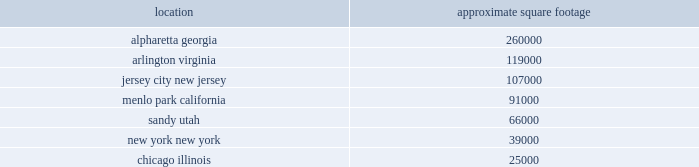Item 2 .
Properties a summary of our significant locations at december 31 , 2011 is shown in the table .
All facilities are leased , except for 165000 square feet of our office in alpharetta , georgia .
Square footage amounts are net of space that has been sublet or part of a facility restructuring. .
All of our facilities are used by either our trading and investing or balance sheet management segments , in addition to the corporate/other category .
All other leased facilities with space of less than 25000 square feet are not listed by location .
In addition to the significant facilities above , we also lease all 28 e*trade branches , ranging in space from approximately 2500 to 7000 square feet .
We believe our facilities space is adequate to meet our needs in 2012 .
Item 3 .
Legal proceedings on october 27 , 2000 , ajaxo , inc .
( 201cajaxo 201d ) filed a complaint in the superior court for the state of california , county of santa clara .
Ajaxo sought damages and certain non-monetary relief for the company 2019s alleged breach of a non-disclosure agreement with ajaxo pertaining to certain wireless technology that ajaxo offered the company as well as damages and other relief against the company for their alleged misappropriation of ajaxo 2019s trade secrets .
Following a jury trial , a judgment was entered in 2003 in favor of ajaxo against the company for $ 1.3 million for breach of the ajaxo non-disclosure agreement .
Although the jury found in favor of ajaxo on its claim against the company for misappropriation of trade secrets , the trial court subsequently denied ajaxo 2019s requests for additional damages and relief .
On december 21 , 2005 , the california court of appeal affirmed the above-described award against the company for breach of the nondisclosure agreement but remanded the case to the trial court for the limited purpose of determining what , if any , additional damages ajaxo may be entitled to as a result of the jury 2019s previous finding in favor of ajaxo on its claim against the company for misappropriation of trade secrets .
Although the company paid ajaxo the full amount due on the above-described judgment , the case was remanded back to the trial court , and on may 30 , 2008 , a jury returned a verdict in favor of the company denying all claims raised and demands for damages against the company .
Following the trial court 2019s filing of entry of judgment in favor of the company on september 5 , 2008 , ajaxo filed post-trial motions for vacating this entry of judgment and requesting a new trial .
By order dated november 4 , 2008 , the trial court denied these motions .
On december 2 , 2008 , ajaxo filed a notice of appeal with the court of appeal of the state of california for the sixth district .
Oral argument on the appeal was heard on july 15 , 2010 .
On august 30 , 2010 , the court of appeal affirmed the trial court 2019s verdict in part and reversed the verdict in part , remanding the case .
E*trade petitioned the supreme court of california for review of the court of appeal decision .
On december 16 , 2010 , the california supreme court denied the company 2019s petition for review and remanded for further proceedings to the trial court .
On september 20 , 2011 , the trial court granted limited discovery at a conference on november 4 , 2011 , and set a motion schedule and trial date .
The trial will continue on may 14 , 2012 .
The company will continue to defend itself vigorously .
On october 2 , 2007 , a class action complaint alleging violations of the federal securities laws was filed in the united states district court for the southern district of new york against the company and its then .
As of december 31 , 2011 what was the ratio of square footage in menlo park california to sandy utah? 
Rationale: as of december 31 , 2011 there was 1.38 square footage in menlo park california to each square foot sandy utah
Computations: (91000 / 66000)
Answer: 1.37879. Item 2 .
Properties a summary of our significant locations at december 31 , 2011 is shown in the table .
All facilities are leased , except for 165000 square feet of our office in alpharetta , georgia .
Square footage amounts are net of space that has been sublet or part of a facility restructuring. .
All of our facilities are used by either our trading and investing or balance sheet management segments , in addition to the corporate/other category .
All other leased facilities with space of less than 25000 square feet are not listed by location .
In addition to the significant facilities above , we also lease all 28 e*trade branches , ranging in space from approximately 2500 to 7000 square feet .
We believe our facilities space is adequate to meet our needs in 2012 .
Item 3 .
Legal proceedings on october 27 , 2000 , ajaxo , inc .
( 201cajaxo 201d ) filed a complaint in the superior court for the state of california , county of santa clara .
Ajaxo sought damages and certain non-monetary relief for the company 2019s alleged breach of a non-disclosure agreement with ajaxo pertaining to certain wireless technology that ajaxo offered the company as well as damages and other relief against the company for their alleged misappropriation of ajaxo 2019s trade secrets .
Following a jury trial , a judgment was entered in 2003 in favor of ajaxo against the company for $ 1.3 million for breach of the ajaxo non-disclosure agreement .
Although the jury found in favor of ajaxo on its claim against the company for misappropriation of trade secrets , the trial court subsequently denied ajaxo 2019s requests for additional damages and relief .
On december 21 , 2005 , the california court of appeal affirmed the above-described award against the company for breach of the nondisclosure agreement but remanded the case to the trial court for the limited purpose of determining what , if any , additional damages ajaxo may be entitled to as a result of the jury 2019s previous finding in favor of ajaxo on its claim against the company for misappropriation of trade secrets .
Although the company paid ajaxo the full amount due on the above-described judgment , the case was remanded back to the trial court , and on may 30 , 2008 , a jury returned a verdict in favor of the company denying all claims raised and demands for damages against the company .
Following the trial court 2019s filing of entry of judgment in favor of the company on september 5 , 2008 , ajaxo filed post-trial motions for vacating this entry of judgment and requesting a new trial .
By order dated november 4 , 2008 , the trial court denied these motions .
On december 2 , 2008 , ajaxo filed a notice of appeal with the court of appeal of the state of california for the sixth district .
Oral argument on the appeal was heard on july 15 , 2010 .
On august 30 , 2010 , the court of appeal affirmed the trial court 2019s verdict in part and reversed the verdict in part , remanding the case .
E*trade petitioned the supreme court of california for review of the court of appeal decision .
On december 16 , 2010 , the california supreme court denied the company 2019s petition for review and remanded for further proceedings to the trial court .
On september 20 , 2011 , the trial court granted limited discovery at a conference on november 4 , 2011 , and set a motion schedule and trial date .
The trial will continue on may 14 , 2012 .
The company will continue to defend itself vigorously .
On october 2 , 2007 , a class action complaint alleging violations of the federal securities laws was filed in the united states district court for the southern district of new york against the company and its then .
As of december 31 , 2011 what was the percent of space not leased space in alpharetta , georgia .? 
Rationale: as of december 31 , 2011 63.5% of space was not leased square footage in alpharetta , georgia .
Computations: (165000 / 260000)
Answer: 0.63462. 